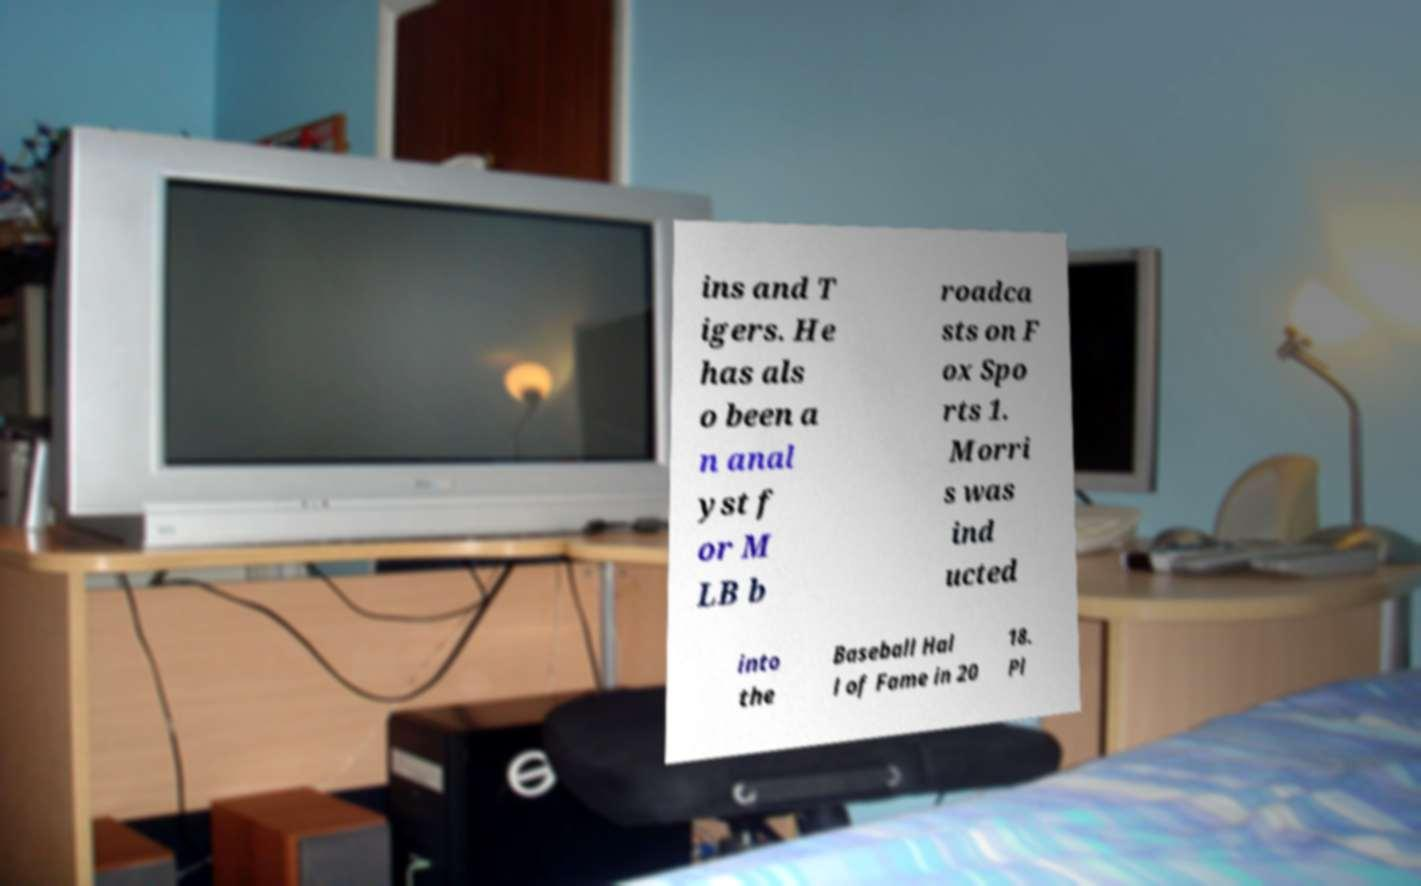There's text embedded in this image that I need extracted. Can you transcribe it verbatim? ins and T igers. He has als o been a n anal yst f or M LB b roadca sts on F ox Spo rts 1. Morri s was ind ucted into the Baseball Hal l of Fame in 20 18. Pl 